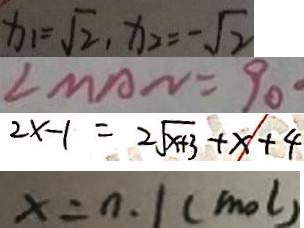Convert formula to latex. <formula><loc_0><loc_0><loc_500><loc_500>x _ { 1 } = \sqrt { 2 } , x _ { 2 } = - \sqrt { 2 } 
 \angle M A N = 9 0 ^ { \circ } 
 2 x - 1 = 2 \sqrt { x + 3 } + x + 4 
 x = n . 1 ( m o l )</formula> 